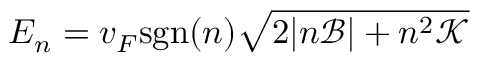<formula> <loc_0><loc_0><loc_500><loc_500>E _ { n } = v _ { F } s g n ( n ) \sqrt { 2 | n \mathcal { B } | + n ^ { 2 } \mathcal { K } }</formula> 